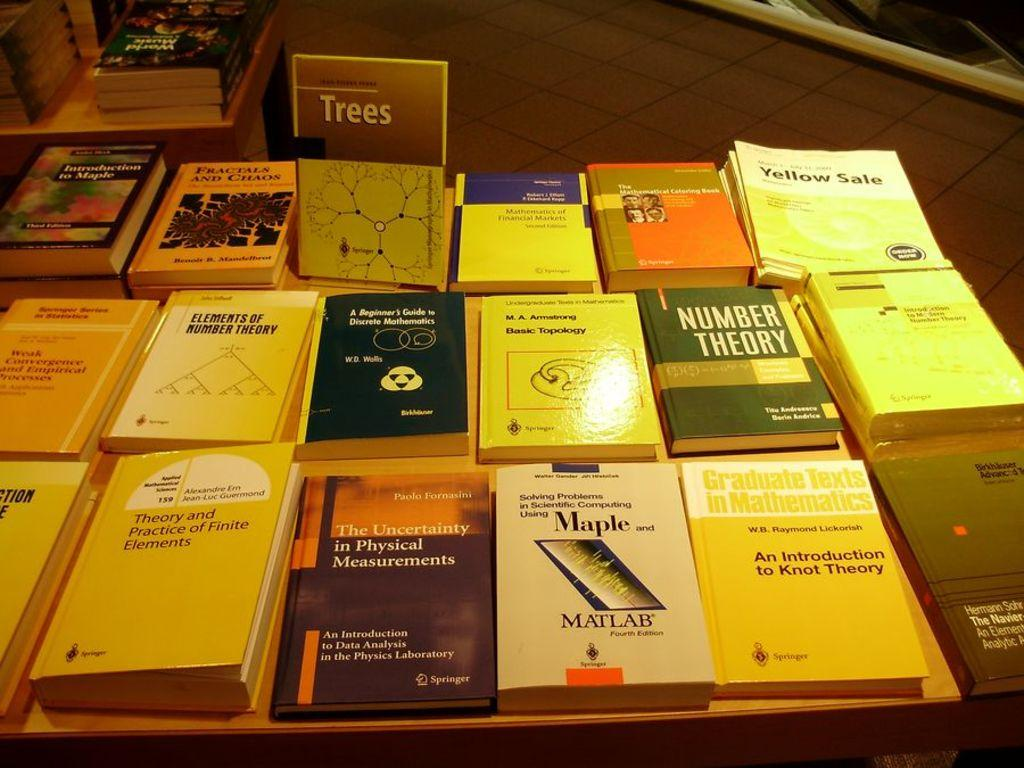<image>
Present a compact description of the photo's key features. A table full of books including one called Trees. 